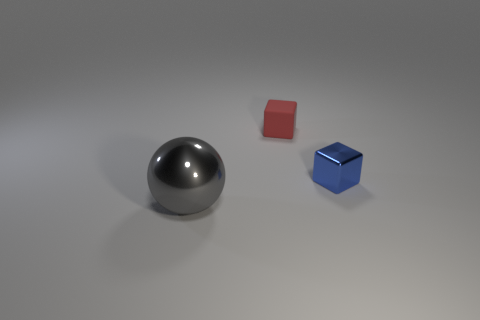Does the shiny thing that is behind the shiny sphere have the same color as the large ball to the left of the matte object?
Ensure brevity in your answer.  No. Are there any other things that are the same material as the sphere?
Ensure brevity in your answer.  Yes. There is another rubber object that is the same shape as the blue thing; what size is it?
Your answer should be very brief. Small. Are there any red cubes on the right side of the small blue thing?
Make the answer very short. No. Are there the same number of spheres that are in front of the large gray metal ball and metallic cubes?
Give a very brief answer. No. There is a thing that is left of the rubber object to the left of the blue metallic cube; is there a tiny metal cube left of it?
Provide a succinct answer. No. What is the material of the large gray sphere?
Make the answer very short. Metal. How many other things are there of the same shape as the blue object?
Your answer should be compact. 1. Is the shape of the tiny metallic object the same as the rubber thing?
Provide a short and direct response. Yes. What number of things are either things that are right of the red rubber object or things that are behind the large gray metal ball?
Offer a terse response. 2. 